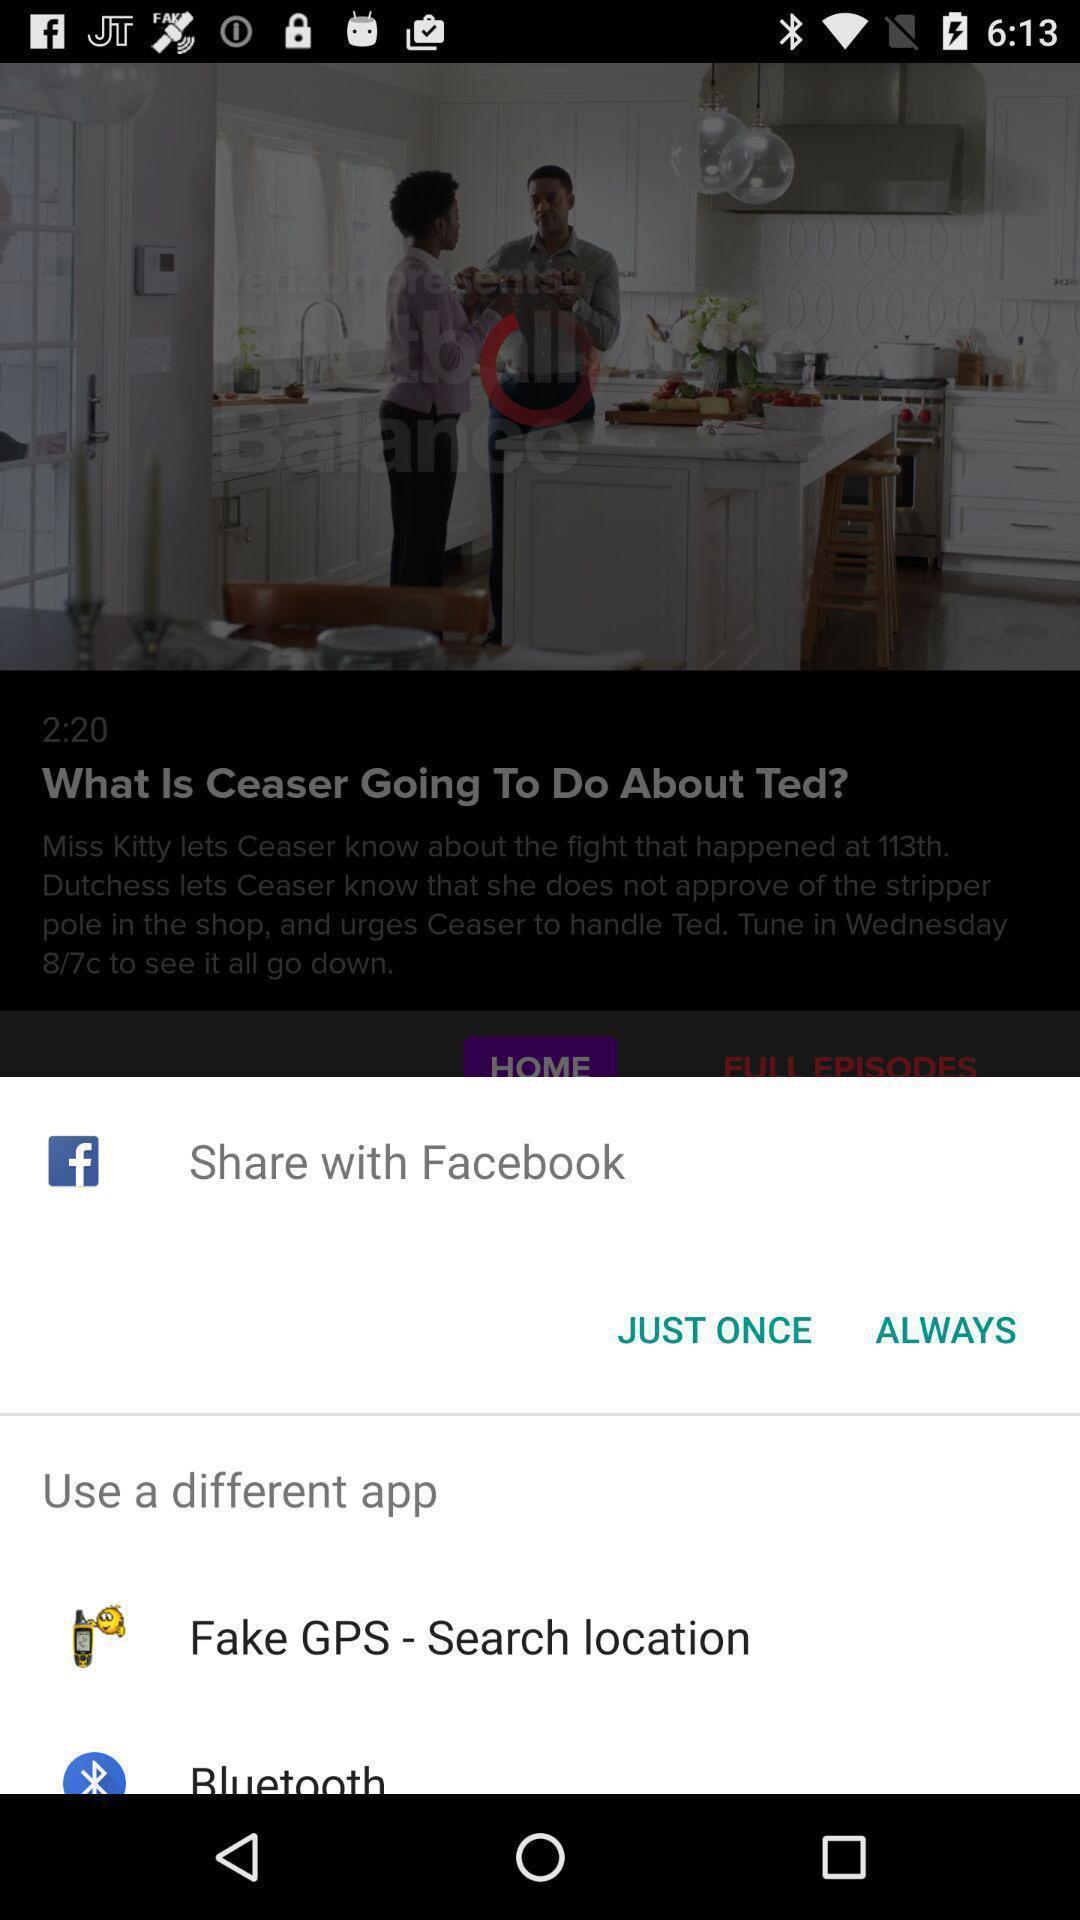What can you discern from this picture? Pop-up showing various share options. 